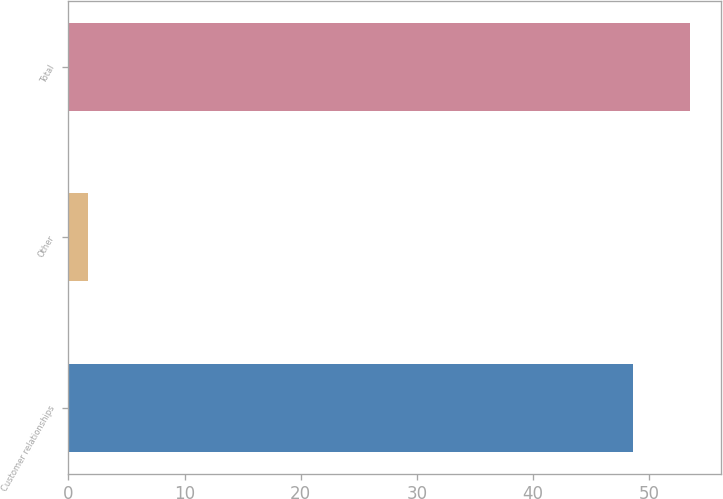Convert chart. <chart><loc_0><loc_0><loc_500><loc_500><bar_chart><fcel>Customer relationships<fcel>Other<fcel>Total<nl><fcel>48.6<fcel>1.7<fcel>53.46<nl></chart> 